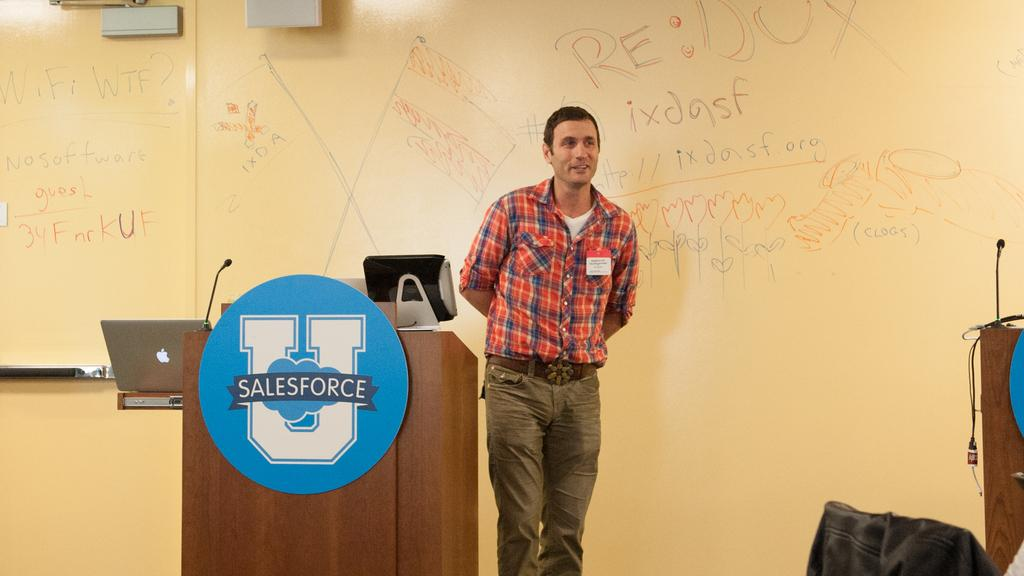What is the main subject of the image? The main subject of the image is a person standing on the stage. What is the person standing beside on the stage? The person is beside a table on the stage. What can be seen at the back of the stage? There is a wall at the back of the stage. What is written or displayed on the wall? There are letters on the wall. What type of rod is being used by the person on the stage? There is no rod visible in the image; the person is simply standing beside a table. 